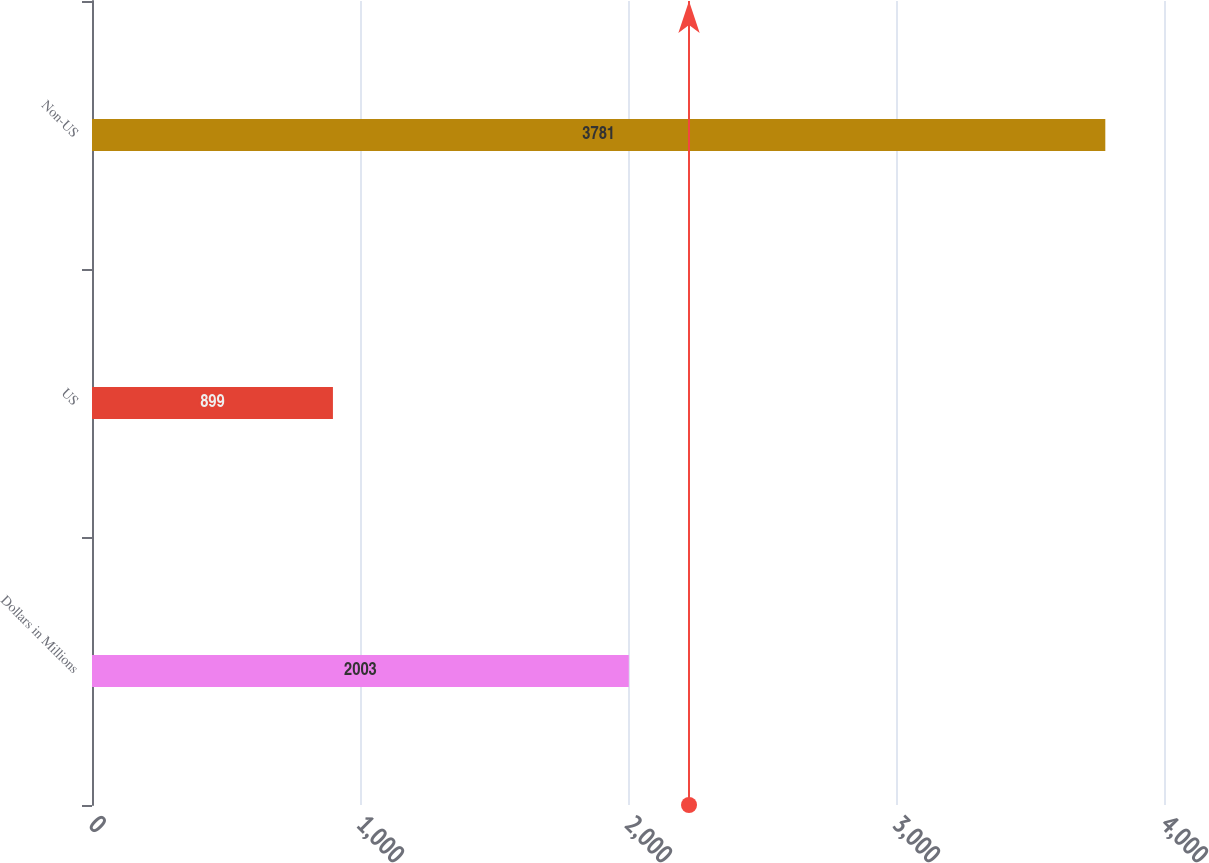Convert chart to OTSL. <chart><loc_0><loc_0><loc_500><loc_500><bar_chart><fcel>Dollars in Millions<fcel>US<fcel>Non-US<nl><fcel>2003<fcel>899<fcel>3781<nl></chart> 